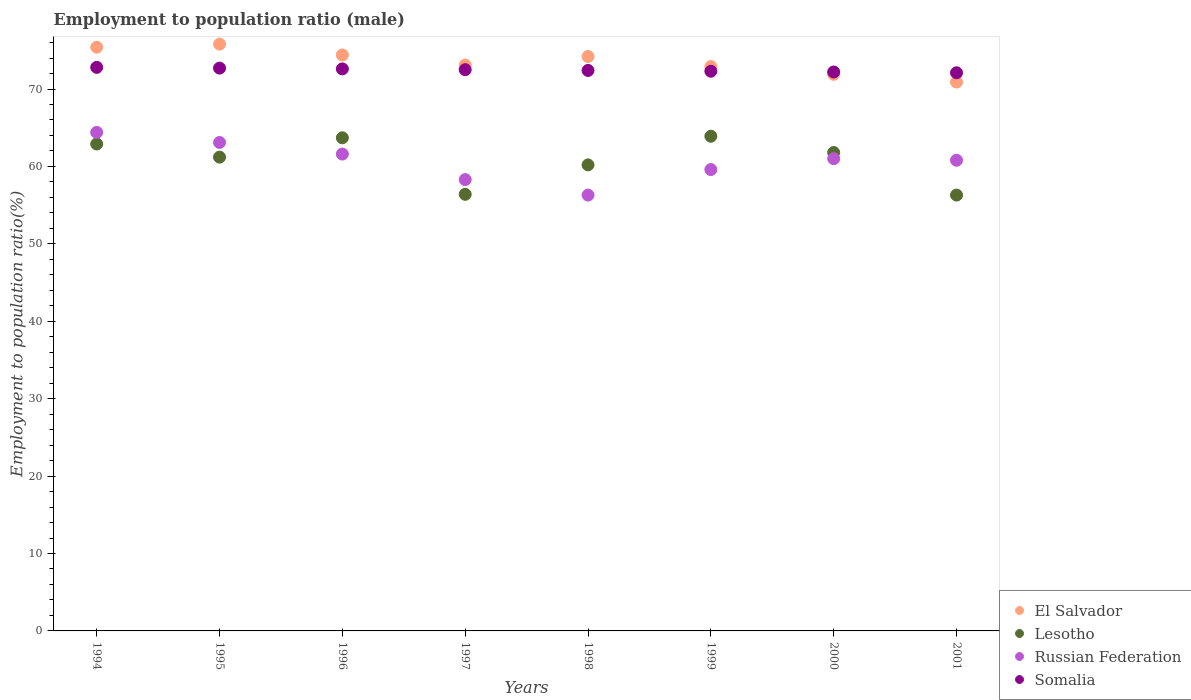Is the number of dotlines equal to the number of legend labels?
Keep it short and to the point. Yes. What is the employment to population ratio in Somalia in 2001?
Provide a short and direct response. 72.1. Across all years, what is the maximum employment to population ratio in Russian Federation?
Provide a short and direct response. 64.4. Across all years, what is the minimum employment to population ratio in Somalia?
Offer a very short reply. 72.1. In which year was the employment to population ratio in Lesotho maximum?
Provide a succinct answer. 1999. What is the total employment to population ratio in El Salvador in the graph?
Your answer should be compact. 588.6. What is the difference between the employment to population ratio in Lesotho in 1997 and that in 1999?
Keep it short and to the point. -7.5. What is the difference between the employment to population ratio in El Salvador in 1995 and the employment to population ratio in Lesotho in 2000?
Provide a short and direct response. 14. What is the average employment to population ratio in El Salvador per year?
Offer a terse response. 73.58. In the year 1995, what is the difference between the employment to population ratio in El Salvador and employment to population ratio in Lesotho?
Your response must be concise. 14.6. What is the ratio of the employment to population ratio in Russian Federation in 1994 to that in 1999?
Keep it short and to the point. 1.08. Is the employment to population ratio in Somalia in 1994 less than that in 1999?
Give a very brief answer. No. Is the difference between the employment to population ratio in El Salvador in 1995 and 1999 greater than the difference between the employment to population ratio in Lesotho in 1995 and 1999?
Ensure brevity in your answer.  Yes. What is the difference between the highest and the second highest employment to population ratio in Somalia?
Your answer should be compact. 0.1. What is the difference between the highest and the lowest employment to population ratio in El Salvador?
Keep it short and to the point. 4.9. Is the sum of the employment to population ratio in Russian Federation in 1997 and 2001 greater than the maximum employment to population ratio in El Salvador across all years?
Ensure brevity in your answer.  Yes. Is it the case that in every year, the sum of the employment to population ratio in Lesotho and employment to population ratio in Somalia  is greater than the sum of employment to population ratio in El Salvador and employment to population ratio in Russian Federation?
Provide a short and direct response. Yes. Is it the case that in every year, the sum of the employment to population ratio in Russian Federation and employment to population ratio in El Salvador  is greater than the employment to population ratio in Somalia?
Give a very brief answer. Yes. Does the employment to population ratio in Lesotho monotonically increase over the years?
Provide a short and direct response. No. Is the employment to population ratio in Somalia strictly less than the employment to population ratio in Lesotho over the years?
Your answer should be compact. No. How many dotlines are there?
Your answer should be compact. 4. Does the graph contain grids?
Provide a short and direct response. No. Where does the legend appear in the graph?
Your answer should be compact. Bottom right. How are the legend labels stacked?
Give a very brief answer. Vertical. What is the title of the graph?
Provide a succinct answer. Employment to population ratio (male). What is the label or title of the Y-axis?
Your response must be concise. Employment to population ratio(%). What is the Employment to population ratio(%) in El Salvador in 1994?
Give a very brief answer. 75.4. What is the Employment to population ratio(%) in Lesotho in 1994?
Your answer should be compact. 62.9. What is the Employment to population ratio(%) in Russian Federation in 1994?
Offer a terse response. 64.4. What is the Employment to population ratio(%) of Somalia in 1994?
Keep it short and to the point. 72.8. What is the Employment to population ratio(%) of El Salvador in 1995?
Your response must be concise. 75.8. What is the Employment to population ratio(%) of Lesotho in 1995?
Offer a terse response. 61.2. What is the Employment to population ratio(%) in Russian Federation in 1995?
Make the answer very short. 63.1. What is the Employment to population ratio(%) of Somalia in 1995?
Your answer should be compact. 72.7. What is the Employment to population ratio(%) of El Salvador in 1996?
Provide a short and direct response. 74.4. What is the Employment to population ratio(%) of Lesotho in 1996?
Your answer should be very brief. 63.7. What is the Employment to population ratio(%) of Russian Federation in 1996?
Give a very brief answer. 61.6. What is the Employment to population ratio(%) of Somalia in 1996?
Make the answer very short. 72.6. What is the Employment to population ratio(%) of El Salvador in 1997?
Offer a terse response. 73.1. What is the Employment to population ratio(%) of Lesotho in 1997?
Your answer should be compact. 56.4. What is the Employment to population ratio(%) in Russian Federation in 1997?
Your answer should be very brief. 58.3. What is the Employment to population ratio(%) in Somalia in 1997?
Your answer should be compact. 72.5. What is the Employment to population ratio(%) of El Salvador in 1998?
Keep it short and to the point. 74.2. What is the Employment to population ratio(%) in Lesotho in 1998?
Your response must be concise. 60.2. What is the Employment to population ratio(%) in Russian Federation in 1998?
Make the answer very short. 56.3. What is the Employment to population ratio(%) in Somalia in 1998?
Offer a terse response. 72.4. What is the Employment to population ratio(%) in El Salvador in 1999?
Your response must be concise. 72.9. What is the Employment to population ratio(%) of Lesotho in 1999?
Your answer should be compact. 63.9. What is the Employment to population ratio(%) of Russian Federation in 1999?
Make the answer very short. 59.6. What is the Employment to population ratio(%) of Somalia in 1999?
Offer a terse response. 72.3. What is the Employment to population ratio(%) of El Salvador in 2000?
Make the answer very short. 71.9. What is the Employment to population ratio(%) of Lesotho in 2000?
Provide a succinct answer. 61.8. What is the Employment to population ratio(%) in Somalia in 2000?
Your answer should be compact. 72.2. What is the Employment to population ratio(%) of El Salvador in 2001?
Keep it short and to the point. 70.9. What is the Employment to population ratio(%) in Lesotho in 2001?
Provide a short and direct response. 56.3. What is the Employment to population ratio(%) in Russian Federation in 2001?
Provide a succinct answer. 60.8. What is the Employment to population ratio(%) of Somalia in 2001?
Make the answer very short. 72.1. Across all years, what is the maximum Employment to population ratio(%) in El Salvador?
Make the answer very short. 75.8. Across all years, what is the maximum Employment to population ratio(%) of Lesotho?
Your response must be concise. 63.9. Across all years, what is the maximum Employment to population ratio(%) of Russian Federation?
Provide a short and direct response. 64.4. Across all years, what is the maximum Employment to population ratio(%) in Somalia?
Keep it short and to the point. 72.8. Across all years, what is the minimum Employment to population ratio(%) in El Salvador?
Your answer should be very brief. 70.9. Across all years, what is the minimum Employment to population ratio(%) in Lesotho?
Provide a short and direct response. 56.3. Across all years, what is the minimum Employment to population ratio(%) of Russian Federation?
Provide a short and direct response. 56.3. Across all years, what is the minimum Employment to population ratio(%) in Somalia?
Ensure brevity in your answer.  72.1. What is the total Employment to population ratio(%) in El Salvador in the graph?
Offer a very short reply. 588.6. What is the total Employment to population ratio(%) of Lesotho in the graph?
Give a very brief answer. 486.4. What is the total Employment to population ratio(%) in Russian Federation in the graph?
Your answer should be compact. 485.1. What is the total Employment to population ratio(%) in Somalia in the graph?
Ensure brevity in your answer.  579.6. What is the difference between the Employment to population ratio(%) in El Salvador in 1994 and that in 1995?
Give a very brief answer. -0.4. What is the difference between the Employment to population ratio(%) in Russian Federation in 1994 and that in 1995?
Offer a terse response. 1.3. What is the difference between the Employment to population ratio(%) in Somalia in 1994 and that in 1996?
Your answer should be very brief. 0.2. What is the difference between the Employment to population ratio(%) in Lesotho in 1994 and that in 1997?
Offer a terse response. 6.5. What is the difference between the Employment to population ratio(%) in Somalia in 1994 and that in 1997?
Your answer should be compact. 0.3. What is the difference between the Employment to population ratio(%) of Lesotho in 1994 and that in 1998?
Give a very brief answer. 2.7. What is the difference between the Employment to population ratio(%) of Somalia in 1994 and that in 1998?
Offer a very short reply. 0.4. What is the difference between the Employment to population ratio(%) of El Salvador in 1994 and that in 1999?
Offer a very short reply. 2.5. What is the difference between the Employment to population ratio(%) in Lesotho in 1994 and that in 1999?
Provide a short and direct response. -1. What is the difference between the Employment to population ratio(%) in El Salvador in 1994 and that in 2000?
Your response must be concise. 3.5. What is the difference between the Employment to population ratio(%) of Russian Federation in 1994 and that in 2000?
Your answer should be very brief. 3.4. What is the difference between the Employment to population ratio(%) of Somalia in 1994 and that in 2001?
Offer a very short reply. 0.7. What is the difference between the Employment to population ratio(%) in El Salvador in 1995 and that in 1996?
Give a very brief answer. 1.4. What is the difference between the Employment to population ratio(%) of Russian Federation in 1995 and that in 1996?
Offer a very short reply. 1.5. What is the difference between the Employment to population ratio(%) of Somalia in 1995 and that in 1996?
Your response must be concise. 0.1. What is the difference between the Employment to population ratio(%) in El Salvador in 1995 and that in 1997?
Offer a terse response. 2.7. What is the difference between the Employment to population ratio(%) in Somalia in 1995 and that in 1997?
Your response must be concise. 0.2. What is the difference between the Employment to population ratio(%) in El Salvador in 1995 and that in 1998?
Offer a terse response. 1.6. What is the difference between the Employment to population ratio(%) of Somalia in 1995 and that in 1998?
Offer a terse response. 0.3. What is the difference between the Employment to population ratio(%) in El Salvador in 1995 and that in 1999?
Your answer should be very brief. 2.9. What is the difference between the Employment to population ratio(%) of Somalia in 1995 and that in 1999?
Ensure brevity in your answer.  0.4. What is the difference between the Employment to population ratio(%) in Russian Federation in 1995 and that in 2001?
Your response must be concise. 2.3. What is the difference between the Employment to population ratio(%) in Lesotho in 1996 and that in 1997?
Offer a terse response. 7.3. What is the difference between the Employment to population ratio(%) of Somalia in 1996 and that in 1997?
Offer a terse response. 0.1. What is the difference between the Employment to population ratio(%) in El Salvador in 1996 and that in 1999?
Provide a succinct answer. 1.5. What is the difference between the Employment to population ratio(%) of El Salvador in 1996 and that in 2000?
Offer a terse response. 2.5. What is the difference between the Employment to population ratio(%) of Somalia in 1996 and that in 2000?
Your response must be concise. 0.4. What is the difference between the Employment to population ratio(%) of Lesotho in 1996 and that in 2001?
Ensure brevity in your answer.  7.4. What is the difference between the Employment to population ratio(%) of Somalia in 1996 and that in 2001?
Offer a very short reply. 0.5. What is the difference between the Employment to population ratio(%) of El Salvador in 1997 and that in 1998?
Keep it short and to the point. -1.1. What is the difference between the Employment to population ratio(%) of Lesotho in 1997 and that in 1998?
Give a very brief answer. -3.8. What is the difference between the Employment to population ratio(%) of El Salvador in 1997 and that in 1999?
Offer a terse response. 0.2. What is the difference between the Employment to population ratio(%) of Lesotho in 1997 and that in 1999?
Your answer should be very brief. -7.5. What is the difference between the Employment to population ratio(%) of El Salvador in 1997 and that in 2000?
Ensure brevity in your answer.  1.2. What is the difference between the Employment to population ratio(%) of Russian Federation in 1997 and that in 2000?
Ensure brevity in your answer.  -2.7. What is the difference between the Employment to population ratio(%) in Somalia in 1997 and that in 2000?
Provide a succinct answer. 0.3. What is the difference between the Employment to population ratio(%) of Lesotho in 1997 and that in 2001?
Provide a short and direct response. 0.1. What is the difference between the Employment to population ratio(%) of Lesotho in 1998 and that in 1999?
Your response must be concise. -3.7. What is the difference between the Employment to population ratio(%) in El Salvador in 1998 and that in 2000?
Provide a succinct answer. 2.3. What is the difference between the Employment to population ratio(%) of Lesotho in 1998 and that in 2000?
Make the answer very short. -1.6. What is the difference between the Employment to population ratio(%) of Somalia in 1998 and that in 2000?
Your response must be concise. 0.2. What is the difference between the Employment to population ratio(%) of El Salvador in 1998 and that in 2001?
Make the answer very short. 3.3. What is the difference between the Employment to population ratio(%) in Lesotho in 1998 and that in 2001?
Your answer should be very brief. 3.9. What is the difference between the Employment to population ratio(%) in El Salvador in 1999 and that in 2000?
Your answer should be compact. 1. What is the difference between the Employment to population ratio(%) of Russian Federation in 1999 and that in 2000?
Your response must be concise. -1.4. What is the difference between the Employment to population ratio(%) in Somalia in 1999 and that in 2000?
Make the answer very short. 0.1. What is the difference between the Employment to population ratio(%) in El Salvador in 1999 and that in 2001?
Offer a terse response. 2. What is the difference between the Employment to population ratio(%) in Lesotho in 1999 and that in 2001?
Offer a terse response. 7.6. What is the difference between the Employment to population ratio(%) of Russian Federation in 1999 and that in 2001?
Provide a short and direct response. -1.2. What is the difference between the Employment to population ratio(%) in Somalia in 1999 and that in 2001?
Provide a succinct answer. 0.2. What is the difference between the Employment to population ratio(%) of El Salvador in 2000 and that in 2001?
Make the answer very short. 1. What is the difference between the Employment to population ratio(%) in Russian Federation in 2000 and that in 2001?
Provide a short and direct response. 0.2. What is the difference between the Employment to population ratio(%) of El Salvador in 1994 and the Employment to population ratio(%) of Russian Federation in 1995?
Your answer should be compact. 12.3. What is the difference between the Employment to population ratio(%) in El Salvador in 1994 and the Employment to population ratio(%) in Somalia in 1995?
Provide a short and direct response. 2.7. What is the difference between the Employment to population ratio(%) in Lesotho in 1994 and the Employment to population ratio(%) in Russian Federation in 1995?
Make the answer very short. -0.2. What is the difference between the Employment to population ratio(%) of El Salvador in 1994 and the Employment to population ratio(%) of Russian Federation in 1996?
Ensure brevity in your answer.  13.8. What is the difference between the Employment to population ratio(%) in Lesotho in 1994 and the Employment to population ratio(%) in Russian Federation in 1996?
Keep it short and to the point. 1.3. What is the difference between the Employment to population ratio(%) in Lesotho in 1994 and the Employment to population ratio(%) in Somalia in 1996?
Your answer should be very brief. -9.7. What is the difference between the Employment to population ratio(%) of El Salvador in 1994 and the Employment to population ratio(%) of Russian Federation in 1997?
Give a very brief answer. 17.1. What is the difference between the Employment to population ratio(%) of El Salvador in 1994 and the Employment to population ratio(%) of Somalia in 1997?
Give a very brief answer. 2.9. What is the difference between the Employment to population ratio(%) of Lesotho in 1994 and the Employment to population ratio(%) of Somalia in 1997?
Ensure brevity in your answer.  -9.6. What is the difference between the Employment to population ratio(%) in El Salvador in 1994 and the Employment to population ratio(%) in Somalia in 1998?
Make the answer very short. 3. What is the difference between the Employment to population ratio(%) of Russian Federation in 1994 and the Employment to population ratio(%) of Somalia in 1999?
Provide a short and direct response. -7.9. What is the difference between the Employment to population ratio(%) in El Salvador in 1994 and the Employment to population ratio(%) in Lesotho in 2000?
Your response must be concise. 13.6. What is the difference between the Employment to population ratio(%) in El Salvador in 1994 and the Employment to population ratio(%) in Somalia in 2000?
Your answer should be compact. 3.2. What is the difference between the Employment to population ratio(%) of Lesotho in 1994 and the Employment to population ratio(%) of Somalia in 2000?
Your answer should be compact. -9.3. What is the difference between the Employment to population ratio(%) in El Salvador in 1994 and the Employment to population ratio(%) in Lesotho in 2001?
Make the answer very short. 19.1. What is the difference between the Employment to population ratio(%) in El Salvador in 1994 and the Employment to population ratio(%) in Russian Federation in 2001?
Make the answer very short. 14.6. What is the difference between the Employment to population ratio(%) in El Salvador in 1995 and the Employment to population ratio(%) in Somalia in 1996?
Make the answer very short. 3.2. What is the difference between the Employment to population ratio(%) in Lesotho in 1995 and the Employment to population ratio(%) in Somalia in 1996?
Provide a short and direct response. -11.4. What is the difference between the Employment to population ratio(%) in Russian Federation in 1995 and the Employment to population ratio(%) in Somalia in 1996?
Make the answer very short. -9.5. What is the difference between the Employment to population ratio(%) in El Salvador in 1995 and the Employment to population ratio(%) in Somalia in 1997?
Provide a succinct answer. 3.3. What is the difference between the Employment to population ratio(%) in Lesotho in 1995 and the Employment to population ratio(%) in Russian Federation in 1997?
Keep it short and to the point. 2.9. What is the difference between the Employment to population ratio(%) of Lesotho in 1995 and the Employment to population ratio(%) of Somalia in 1997?
Ensure brevity in your answer.  -11.3. What is the difference between the Employment to population ratio(%) in Russian Federation in 1995 and the Employment to population ratio(%) in Somalia in 1997?
Make the answer very short. -9.4. What is the difference between the Employment to population ratio(%) in El Salvador in 1995 and the Employment to population ratio(%) in Lesotho in 1998?
Your response must be concise. 15.6. What is the difference between the Employment to population ratio(%) of Lesotho in 1995 and the Employment to population ratio(%) of Russian Federation in 1998?
Offer a terse response. 4.9. What is the difference between the Employment to population ratio(%) in Lesotho in 1995 and the Employment to population ratio(%) in Somalia in 1998?
Keep it short and to the point. -11.2. What is the difference between the Employment to population ratio(%) in Russian Federation in 1995 and the Employment to population ratio(%) in Somalia in 1998?
Provide a short and direct response. -9.3. What is the difference between the Employment to population ratio(%) of El Salvador in 1995 and the Employment to population ratio(%) of Lesotho in 1999?
Make the answer very short. 11.9. What is the difference between the Employment to population ratio(%) in El Salvador in 1995 and the Employment to population ratio(%) in Somalia in 1999?
Ensure brevity in your answer.  3.5. What is the difference between the Employment to population ratio(%) in Lesotho in 1995 and the Employment to population ratio(%) in Russian Federation in 1999?
Your response must be concise. 1.6. What is the difference between the Employment to population ratio(%) in Lesotho in 1995 and the Employment to population ratio(%) in Somalia in 1999?
Provide a short and direct response. -11.1. What is the difference between the Employment to population ratio(%) in El Salvador in 1995 and the Employment to population ratio(%) in Lesotho in 2000?
Your response must be concise. 14. What is the difference between the Employment to population ratio(%) of Lesotho in 1995 and the Employment to population ratio(%) of Russian Federation in 2001?
Offer a very short reply. 0.4. What is the difference between the Employment to population ratio(%) in Lesotho in 1995 and the Employment to population ratio(%) in Somalia in 2001?
Provide a succinct answer. -10.9. What is the difference between the Employment to population ratio(%) of El Salvador in 1996 and the Employment to population ratio(%) of Lesotho in 1997?
Offer a terse response. 18. What is the difference between the Employment to population ratio(%) in El Salvador in 1996 and the Employment to population ratio(%) in Somalia in 1997?
Make the answer very short. 1.9. What is the difference between the Employment to population ratio(%) of Lesotho in 1996 and the Employment to population ratio(%) of Somalia in 1997?
Your answer should be very brief. -8.8. What is the difference between the Employment to population ratio(%) of El Salvador in 1996 and the Employment to population ratio(%) of Lesotho in 1998?
Make the answer very short. 14.2. What is the difference between the Employment to population ratio(%) of El Salvador in 1996 and the Employment to population ratio(%) of Somalia in 1998?
Provide a short and direct response. 2. What is the difference between the Employment to population ratio(%) of Lesotho in 1996 and the Employment to population ratio(%) of Russian Federation in 1998?
Provide a succinct answer. 7.4. What is the difference between the Employment to population ratio(%) of El Salvador in 1996 and the Employment to population ratio(%) of Russian Federation in 1999?
Your response must be concise. 14.8. What is the difference between the Employment to population ratio(%) of Lesotho in 1996 and the Employment to population ratio(%) of Russian Federation in 1999?
Give a very brief answer. 4.1. What is the difference between the Employment to population ratio(%) of Russian Federation in 1996 and the Employment to population ratio(%) of Somalia in 1999?
Offer a terse response. -10.7. What is the difference between the Employment to population ratio(%) in El Salvador in 1996 and the Employment to population ratio(%) in Russian Federation in 2000?
Ensure brevity in your answer.  13.4. What is the difference between the Employment to population ratio(%) of Lesotho in 1996 and the Employment to population ratio(%) of Russian Federation in 2000?
Keep it short and to the point. 2.7. What is the difference between the Employment to population ratio(%) in El Salvador in 1996 and the Employment to population ratio(%) in Lesotho in 2001?
Your answer should be very brief. 18.1. What is the difference between the Employment to population ratio(%) of El Salvador in 1996 and the Employment to population ratio(%) of Russian Federation in 2001?
Make the answer very short. 13.6. What is the difference between the Employment to population ratio(%) in El Salvador in 1996 and the Employment to population ratio(%) in Somalia in 2001?
Your answer should be very brief. 2.3. What is the difference between the Employment to population ratio(%) of Russian Federation in 1996 and the Employment to population ratio(%) of Somalia in 2001?
Make the answer very short. -10.5. What is the difference between the Employment to population ratio(%) in El Salvador in 1997 and the Employment to population ratio(%) in Lesotho in 1998?
Give a very brief answer. 12.9. What is the difference between the Employment to population ratio(%) of El Salvador in 1997 and the Employment to population ratio(%) of Russian Federation in 1998?
Ensure brevity in your answer.  16.8. What is the difference between the Employment to population ratio(%) in El Salvador in 1997 and the Employment to population ratio(%) in Somalia in 1998?
Offer a very short reply. 0.7. What is the difference between the Employment to population ratio(%) in Lesotho in 1997 and the Employment to population ratio(%) in Russian Federation in 1998?
Give a very brief answer. 0.1. What is the difference between the Employment to population ratio(%) in Lesotho in 1997 and the Employment to population ratio(%) in Somalia in 1998?
Your answer should be compact. -16. What is the difference between the Employment to population ratio(%) of Russian Federation in 1997 and the Employment to population ratio(%) of Somalia in 1998?
Keep it short and to the point. -14.1. What is the difference between the Employment to population ratio(%) in El Salvador in 1997 and the Employment to population ratio(%) in Somalia in 1999?
Provide a succinct answer. 0.8. What is the difference between the Employment to population ratio(%) of Lesotho in 1997 and the Employment to population ratio(%) of Russian Federation in 1999?
Offer a terse response. -3.2. What is the difference between the Employment to population ratio(%) of Lesotho in 1997 and the Employment to population ratio(%) of Somalia in 1999?
Offer a very short reply. -15.9. What is the difference between the Employment to population ratio(%) in Lesotho in 1997 and the Employment to population ratio(%) in Russian Federation in 2000?
Keep it short and to the point. -4.6. What is the difference between the Employment to population ratio(%) in Lesotho in 1997 and the Employment to population ratio(%) in Somalia in 2000?
Give a very brief answer. -15.8. What is the difference between the Employment to population ratio(%) in Lesotho in 1997 and the Employment to population ratio(%) in Russian Federation in 2001?
Your answer should be compact. -4.4. What is the difference between the Employment to population ratio(%) of Lesotho in 1997 and the Employment to population ratio(%) of Somalia in 2001?
Provide a succinct answer. -15.7. What is the difference between the Employment to population ratio(%) of El Salvador in 1998 and the Employment to population ratio(%) of Lesotho in 1999?
Your answer should be compact. 10.3. What is the difference between the Employment to population ratio(%) of El Salvador in 1998 and the Employment to population ratio(%) of Russian Federation in 1999?
Make the answer very short. 14.6. What is the difference between the Employment to population ratio(%) in Lesotho in 1998 and the Employment to population ratio(%) in Somalia in 1999?
Provide a succinct answer. -12.1. What is the difference between the Employment to population ratio(%) in Russian Federation in 1998 and the Employment to population ratio(%) in Somalia in 1999?
Make the answer very short. -16. What is the difference between the Employment to population ratio(%) of El Salvador in 1998 and the Employment to population ratio(%) of Lesotho in 2000?
Offer a terse response. 12.4. What is the difference between the Employment to population ratio(%) of El Salvador in 1998 and the Employment to population ratio(%) of Russian Federation in 2000?
Give a very brief answer. 13.2. What is the difference between the Employment to population ratio(%) in Lesotho in 1998 and the Employment to population ratio(%) in Russian Federation in 2000?
Your answer should be compact. -0.8. What is the difference between the Employment to population ratio(%) of Lesotho in 1998 and the Employment to population ratio(%) of Somalia in 2000?
Make the answer very short. -12. What is the difference between the Employment to population ratio(%) of Russian Federation in 1998 and the Employment to population ratio(%) of Somalia in 2000?
Ensure brevity in your answer.  -15.9. What is the difference between the Employment to population ratio(%) of El Salvador in 1998 and the Employment to population ratio(%) of Russian Federation in 2001?
Your response must be concise. 13.4. What is the difference between the Employment to population ratio(%) of El Salvador in 1998 and the Employment to population ratio(%) of Somalia in 2001?
Ensure brevity in your answer.  2.1. What is the difference between the Employment to population ratio(%) in Lesotho in 1998 and the Employment to population ratio(%) in Russian Federation in 2001?
Give a very brief answer. -0.6. What is the difference between the Employment to population ratio(%) in Russian Federation in 1998 and the Employment to population ratio(%) in Somalia in 2001?
Your response must be concise. -15.8. What is the difference between the Employment to population ratio(%) of El Salvador in 1999 and the Employment to population ratio(%) of Lesotho in 2000?
Ensure brevity in your answer.  11.1. What is the difference between the Employment to population ratio(%) in El Salvador in 1999 and the Employment to population ratio(%) in Russian Federation in 2000?
Provide a succinct answer. 11.9. What is the difference between the Employment to population ratio(%) in Lesotho in 1999 and the Employment to population ratio(%) in Russian Federation in 2000?
Offer a very short reply. 2.9. What is the difference between the Employment to population ratio(%) of Russian Federation in 1999 and the Employment to population ratio(%) of Somalia in 2000?
Offer a terse response. -12.6. What is the difference between the Employment to population ratio(%) in El Salvador in 1999 and the Employment to population ratio(%) in Russian Federation in 2001?
Your answer should be compact. 12.1. What is the difference between the Employment to population ratio(%) of El Salvador in 1999 and the Employment to population ratio(%) of Somalia in 2001?
Provide a short and direct response. 0.8. What is the difference between the Employment to population ratio(%) in Lesotho in 1999 and the Employment to population ratio(%) in Russian Federation in 2001?
Make the answer very short. 3.1. What is the difference between the Employment to population ratio(%) in Lesotho in 1999 and the Employment to population ratio(%) in Somalia in 2001?
Provide a succinct answer. -8.2. What is the difference between the Employment to population ratio(%) of El Salvador in 2000 and the Employment to population ratio(%) of Lesotho in 2001?
Provide a succinct answer. 15.6. What is the difference between the Employment to population ratio(%) of Russian Federation in 2000 and the Employment to population ratio(%) of Somalia in 2001?
Ensure brevity in your answer.  -11.1. What is the average Employment to population ratio(%) of El Salvador per year?
Your response must be concise. 73.58. What is the average Employment to population ratio(%) of Lesotho per year?
Your answer should be compact. 60.8. What is the average Employment to population ratio(%) in Russian Federation per year?
Offer a terse response. 60.64. What is the average Employment to population ratio(%) of Somalia per year?
Offer a terse response. 72.45. In the year 1994, what is the difference between the Employment to population ratio(%) of El Salvador and Employment to population ratio(%) of Russian Federation?
Your answer should be very brief. 11. In the year 1994, what is the difference between the Employment to population ratio(%) of Lesotho and Employment to population ratio(%) of Russian Federation?
Provide a short and direct response. -1.5. In the year 1995, what is the difference between the Employment to population ratio(%) of El Salvador and Employment to population ratio(%) of Lesotho?
Offer a very short reply. 14.6. In the year 1995, what is the difference between the Employment to population ratio(%) of El Salvador and Employment to population ratio(%) of Russian Federation?
Offer a very short reply. 12.7. In the year 1995, what is the difference between the Employment to population ratio(%) in Lesotho and Employment to population ratio(%) in Russian Federation?
Offer a very short reply. -1.9. In the year 1996, what is the difference between the Employment to population ratio(%) in El Salvador and Employment to population ratio(%) in Lesotho?
Offer a very short reply. 10.7. In the year 1996, what is the difference between the Employment to population ratio(%) in El Salvador and Employment to population ratio(%) in Somalia?
Provide a short and direct response. 1.8. In the year 1996, what is the difference between the Employment to population ratio(%) of Lesotho and Employment to population ratio(%) of Russian Federation?
Your response must be concise. 2.1. In the year 1996, what is the difference between the Employment to population ratio(%) in Lesotho and Employment to population ratio(%) in Somalia?
Provide a succinct answer. -8.9. In the year 1996, what is the difference between the Employment to population ratio(%) of Russian Federation and Employment to population ratio(%) of Somalia?
Your response must be concise. -11. In the year 1997, what is the difference between the Employment to population ratio(%) in Lesotho and Employment to population ratio(%) in Somalia?
Give a very brief answer. -16.1. In the year 1998, what is the difference between the Employment to population ratio(%) in El Salvador and Employment to population ratio(%) in Lesotho?
Offer a very short reply. 14. In the year 1998, what is the difference between the Employment to population ratio(%) in El Salvador and Employment to population ratio(%) in Russian Federation?
Ensure brevity in your answer.  17.9. In the year 1998, what is the difference between the Employment to population ratio(%) of El Salvador and Employment to population ratio(%) of Somalia?
Your response must be concise. 1.8. In the year 1998, what is the difference between the Employment to population ratio(%) of Lesotho and Employment to population ratio(%) of Russian Federation?
Keep it short and to the point. 3.9. In the year 1998, what is the difference between the Employment to population ratio(%) of Lesotho and Employment to population ratio(%) of Somalia?
Your response must be concise. -12.2. In the year 1998, what is the difference between the Employment to population ratio(%) of Russian Federation and Employment to population ratio(%) of Somalia?
Provide a succinct answer. -16.1. In the year 1999, what is the difference between the Employment to population ratio(%) in El Salvador and Employment to population ratio(%) in Russian Federation?
Make the answer very short. 13.3. In the year 1999, what is the difference between the Employment to population ratio(%) of El Salvador and Employment to population ratio(%) of Somalia?
Offer a very short reply. 0.6. In the year 2000, what is the difference between the Employment to population ratio(%) of El Salvador and Employment to population ratio(%) of Lesotho?
Ensure brevity in your answer.  10.1. In the year 2000, what is the difference between the Employment to population ratio(%) in El Salvador and Employment to population ratio(%) in Somalia?
Offer a very short reply. -0.3. In the year 2000, what is the difference between the Employment to population ratio(%) of Lesotho and Employment to population ratio(%) of Russian Federation?
Your response must be concise. 0.8. In the year 2001, what is the difference between the Employment to population ratio(%) of El Salvador and Employment to population ratio(%) of Lesotho?
Your answer should be compact. 14.6. In the year 2001, what is the difference between the Employment to population ratio(%) of Lesotho and Employment to population ratio(%) of Somalia?
Your answer should be very brief. -15.8. What is the ratio of the Employment to population ratio(%) in El Salvador in 1994 to that in 1995?
Your response must be concise. 0.99. What is the ratio of the Employment to population ratio(%) of Lesotho in 1994 to that in 1995?
Keep it short and to the point. 1.03. What is the ratio of the Employment to population ratio(%) of Russian Federation in 1994 to that in 1995?
Keep it short and to the point. 1.02. What is the ratio of the Employment to population ratio(%) of Somalia in 1994 to that in 1995?
Provide a short and direct response. 1. What is the ratio of the Employment to population ratio(%) in El Salvador in 1994 to that in 1996?
Offer a terse response. 1.01. What is the ratio of the Employment to population ratio(%) in Lesotho in 1994 to that in 1996?
Give a very brief answer. 0.99. What is the ratio of the Employment to population ratio(%) of Russian Federation in 1994 to that in 1996?
Keep it short and to the point. 1.05. What is the ratio of the Employment to population ratio(%) of El Salvador in 1994 to that in 1997?
Provide a short and direct response. 1.03. What is the ratio of the Employment to population ratio(%) in Lesotho in 1994 to that in 1997?
Ensure brevity in your answer.  1.12. What is the ratio of the Employment to population ratio(%) in Russian Federation in 1994 to that in 1997?
Make the answer very short. 1.1. What is the ratio of the Employment to population ratio(%) in Somalia in 1994 to that in 1997?
Provide a short and direct response. 1. What is the ratio of the Employment to population ratio(%) of El Salvador in 1994 to that in 1998?
Make the answer very short. 1.02. What is the ratio of the Employment to population ratio(%) in Lesotho in 1994 to that in 1998?
Offer a very short reply. 1.04. What is the ratio of the Employment to population ratio(%) in Russian Federation in 1994 to that in 1998?
Give a very brief answer. 1.14. What is the ratio of the Employment to population ratio(%) of El Salvador in 1994 to that in 1999?
Your answer should be compact. 1.03. What is the ratio of the Employment to population ratio(%) in Lesotho in 1994 to that in 1999?
Offer a very short reply. 0.98. What is the ratio of the Employment to population ratio(%) of Russian Federation in 1994 to that in 1999?
Make the answer very short. 1.08. What is the ratio of the Employment to population ratio(%) in Somalia in 1994 to that in 1999?
Provide a short and direct response. 1.01. What is the ratio of the Employment to population ratio(%) of El Salvador in 1994 to that in 2000?
Provide a short and direct response. 1.05. What is the ratio of the Employment to population ratio(%) in Lesotho in 1994 to that in 2000?
Your response must be concise. 1.02. What is the ratio of the Employment to population ratio(%) in Russian Federation in 1994 to that in 2000?
Give a very brief answer. 1.06. What is the ratio of the Employment to population ratio(%) in Somalia in 1994 to that in 2000?
Your answer should be very brief. 1.01. What is the ratio of the Employment to population ratio(%) in El Salvador in 1994 to that in 2001?
Keep it short and to the point. 1.06. What is the ratio of the Employment to population ratio(%) in Lesotho in 1994 to that in 2001?
Provide a succinct answer. 1.12. What is the ratio of the Employment to population ratio(%) in Russian Federation in 1994 to that in 2001?
Offer a very short reply. 1.06. What is the ratio of the Employment to population ratio(%) in Somalia in 1994 to that in 2001?
Your answer should be very brief. 1.01. What is the ratio of the Employment to population ratio(%) in El Salvador in 1995 to that in 1996?
Offer a terse response. 1.02. What is the ratio of the Employment to population ratio(%) of Lesotho in 1995 to that in 1996?
Give a very brief answer. 0.96. What is the ratio of the Employment to population ratio(%) in Russian Federation in 1995 to that in 1996?
Ensure brevity in your answer.  1.02. What is the ratio of the Employment to population ratio(%) in Somalia in 1995 to that in 1996?
Your answer should be very brief. 1. What is the ratio of the Employment to population ratio(%) in El Salvador in 1995 to that in 1997?
Give a very brief answer. 1.04. What is the ratio of the Employment to population ratio(%) in Lesotho in 1995 to that in 1997?
Offer a terse response. 1.09. What is the ratio of the Employment to population ratio(%) of Russian Federation in 1995 to that in 1997?
Ensure brevity in your answer.  1.08. What is the ratio of the Employment to population ratio(%) in El Salvador in 1995 to that in 1998?
Ensure brevity in your answer.  1.02. What is the ratio of the Employment to population ratio(%) of Lesotho in 1995 to that in 1998?
Ensure brevity in your answer.  1.02. What is the ratio of the Employment to population ratio(%) of Russian Federation in 1995 to that in 1998?
Provide a short and direct response. 1.12. What is the ratio of the Employment to population ratio(%) in El Salvador in 1995 to that in 1999?
Give a very brief answer. 1.04. What is the ratio of the Employment to population ratio(%) of Lesotho in 1995 to that in 1999?
Offer a very short reply. 0.96. What is the ratio of the Employment to population ratio(%) in Russian Federation in 1995 to that in 1999?
Your response must be concise. 1.06. What is the ratio of the Employment to population ratio(%) in El Salvador in 1995 to that in 2000?
Your answer should be compact. 1.05. What is the ratio of the Employment to population ratio(%) in Lesotho in 1995 to that in 2000?
Give a very brief answer. 0.99. What is the ratio of the Employment to population ratio(%) of Russian Federation in 1995 to that in 2000?
Ensure brevity in your answer.  1.03. What is the ratio of the Employment to population ratio(%) of El Salvador in 1995 to that in 2001?
Provide a short and direct response. 1.07. What is the ratio of the Employment to population ratio(%) in Lesotho in 1995 to that in 2001?
Ensure brevity in your answer.  1.09. What is the ratio of the Employment to population ratio(%) in Russian Federation in 1995 to that in 2001?
Offer a very short reply. 1.04. What is the ratio of the Employment to population ratio(%) in Somalia in 1995 to that in 2001?
Your response must be concise. 1.01. What is the ratio of the Employment to population ratio(%) in El Salvador in 1996 to that in 1997?
Your answer should be very brief. 1.02. What is the ratio of the Employment to population ratio(%) of Lesotho in 1996 to that in 1997?
Your response must be concise. 1.13. What is the ratio of the Employment to population ratio(%) in Russian Federation in 1996 to that in 1997?
Make the answer very short. 1.06. What is the ratio of the Employment to population ratio(%) of Somalia in 1996 to that in 1997?
Make the answer very short. 1. What is the ratio of the Employment to population ratio(%) in El Salvador in 1996 to that in 1998?
Your response must be concise. 1. What is the ratio of the Employment to population ratio(%) in Lesotho in 1996 to that in 1998?
Ensure brevity in your answer.  1.06. What is the ratio of the Employment to population ratio(%) in Russian Federation in 1996 to that in 1998?
Your answer should be compact. 1.09. What is the ratio of the Employment to population ratio(%) of El Salvador in 1996 to that in 1999?
Your answer should be compact. 1.02. What is the ratio of the Employment to population ratio(%) of Russian Federation in 1996 to that in 1999?
Your answer should be compact. 1.03. What is the ratio of the Employment to population ratio(%) of El Salvador in 1996 to that in 2000?
Your answer should be very brief. 1.03. What is the ratio of the Employment to population ratio(%) in Lesotho in 1996 to that in 2000?
Make the answer very short. 1.03. What is the ratio of the Employment to population ratio(%) of Russian Federation in 1996 to that in 2000?
Provide a short and direct response. 1.01. What is the ratio of the Employment to population ratio(%) of Somalia in 1996 to that in 2000?
Offer a terse response. 1.01. What is the ratio of the Employment to population ratio(%) in El Salvador in 1996 to that in 2001?
Give a very brief answer. 1.05. What is the ratio of the Employment to population ratio(%) of Lesotho in 1996 to that in 2001?
Offer a terse response. 1.13. What is the ratio of the Employment to population ratio(%) of Russian Federation in 1996 to that in 2001?
Ensure brevity in your answer.  1.01. What is the ratio of the Employment to population ratio(%) of Somalia in 1996 to that in 2001?
Your answer should be very brief. 1.01. What is the ratio of the Employment to population ratio(%) of El Salvador in 1997 to that in 1998?
Keep it short and to the point. 0.99. What is the ratio of the Employment to population ratio(%) in Lesotho in 1997 to that in 1998?
Offer a terse response. 0.94. What is the ratio of the Employment to population ratio(%) of Russian Federation in 1997 to that in 1998?
Your answer should be very brief. 1.04. What is the ratio of the Employment to population ratio(%) of Lesotho in 1997 to that in 1999?
Your answer should be compact. 0.88. What is the ratio of the Employment to population ratio(%) of Russian Federation in 1997 to that in 1999?
Ensure brevity in your answer.  0.98. What is the ratio of the Employment to population ratio(%) in Somalia in 1997 to that in 1999?
Ensure brevity in your answer.  1. What is the ratio of the Employment to population ratio(%) of El Salvador in 1997 to that in 2000?
Your answer should be compact. 1.02. What is the ratio of the Employment to population ratio(%) in Lesotho in 1997 to that in 2000?
Your response must be concise. 0.91. What is the ratio of the Employment to population ratio(%) in Russian Federation in 1997 to that in 2000?
Give a very brief answer. 0.96. What is the ratio of the Employment to population ratio(%) in El Salvador in 1997 to that in 2001?
Offer a terse response. 1.03. What is the ratio of the Employment to population ratio(%) in Russian Federation in 1997 to that in 2001?
Keep it short and to the point. 0.96. What is the ratio of the Employment to population ratio(%) of Somalia in 1997 to that in 2001?
Keep it short and to the point. 1.01. What is the ratio of the Employment to population ratio(%) in El Salvador in 1998 to that in 1999?
Your answer should be very brief. 1.02. What is the ratio of the Employment to population ratio(%) of Lesotho in 1998 to that in 1999?
Keep it short and to the point. 0.94. What is the ratio of the Employment to population ratio(%) in Russian Federation in 1998 to that in 1999?
Make the answer very short. 0.94. What is the ratio of the Employment to population ratio(%) of Somalia in 1998 to that in 1999?
Offer a terse response. 1. What is the ratio of the Employment to population ratio(%) of El Salvador in 1998 to that in 2000?
Your answer should be very brief. 1.03. What is the ratio of the Employment to population ratio(%) of Lesotho in 1998 to that in 2000?
Keep it short and to the point. 0.97. What is the ratio of the Employment to population ratio(%) in Russian Federation in 1998 to that in 2000?
Ensure brevity in your answer.  0.92. What is the ratio of the Employment to population ratio(%) of El Salvador in 1998 to that in 2001?
Provide a succinct answer. 1.05. What is the ratio of the Employment to population ratio(%) of Lesotho in 1998 to that in 2001?
Your answer should be compact. 1.07. What is the ratio of the Employment to population ratio(%) in Russian Federation in 1998 to that in 2001?
Offer a terse response. 0.93. What is the ratio of the Employment to population ratio(%) of Somalia in 1998 to that in 2001?
Your answer should be very brief. 1. What is the ratio of the Employment to population ratio(%) of El Salvador in 1999 to that in 2000?
Ensure brevity in your answer.  1.01. What is the ratio of the Employment to population ratio(%) of Lesotho in 1999 to that in 2000?
Offer a very short reply. 1.03. What is the ratio of the Employment to population ratio(%) in Russian Federation in 1999 to that in 2000?
Give a very brief answer. 0.98. What is the ratio of the Employment to population ratio(%) of Somalia in 1999 to that in 2000?
Offer a very short reply. 1. What is the ratio of the Employment to population ratio(%) of El Salvador in 1999 to that in 2001?
Give a very brief answer. 1.03. What is the ratio of the Employment to population ratio(%) in Lesotho in 1999 to that in 2001?
Keep it short and to the point. 1.14. What is the ratio of the Employment to population ratio(%) of Russian Federation in 1999 to that in 2001?
Give a very brief answer. 0.98. What is the ratio of the Employment to population ratio(%) of Somalia in 1999 to that in 2001?
Give a very brief answer. 1. What is the ratio of the Employment to population ratio(%) of El Salvador in 2000 to that in 2001?
Offer a very short reply. 1.01. What is the ratio of the Employment to population ratio(%) of Lesotho in 2000 to that in 2001?
Provide a short and direct response. 1.1. What is the ratio of the Employment to population ratio(%) in Russian Federation in 2000 to that in 2001?
Make the answer very short. 1. What is the difference between the highest and the second highest Employment to population ratio(%) of El Salvador?
Make the answer very short. 0.4. What is the difference between the highest and the second highest Employment to population ratio(%) in Lesotho?
Keep it short and to the point. 0.2. What is the difference between the highest and the lowest Employment to population ratio(%) of El Salvador?
Your answer should be compact. 4.9. What is the difference between the highest and the lowest Employment to population ratio(%) in Lesotho?
Provide a succinct answer. 7.6. What is the difference between the highest and the lowest Employment to population ratio(%) of Russian Federation?
Your answer should be very brief. 8.1. What is the difference between the highest and the lowest Employment to population ratio(%) of Somalia?
Your response must be concise. 0.7. 